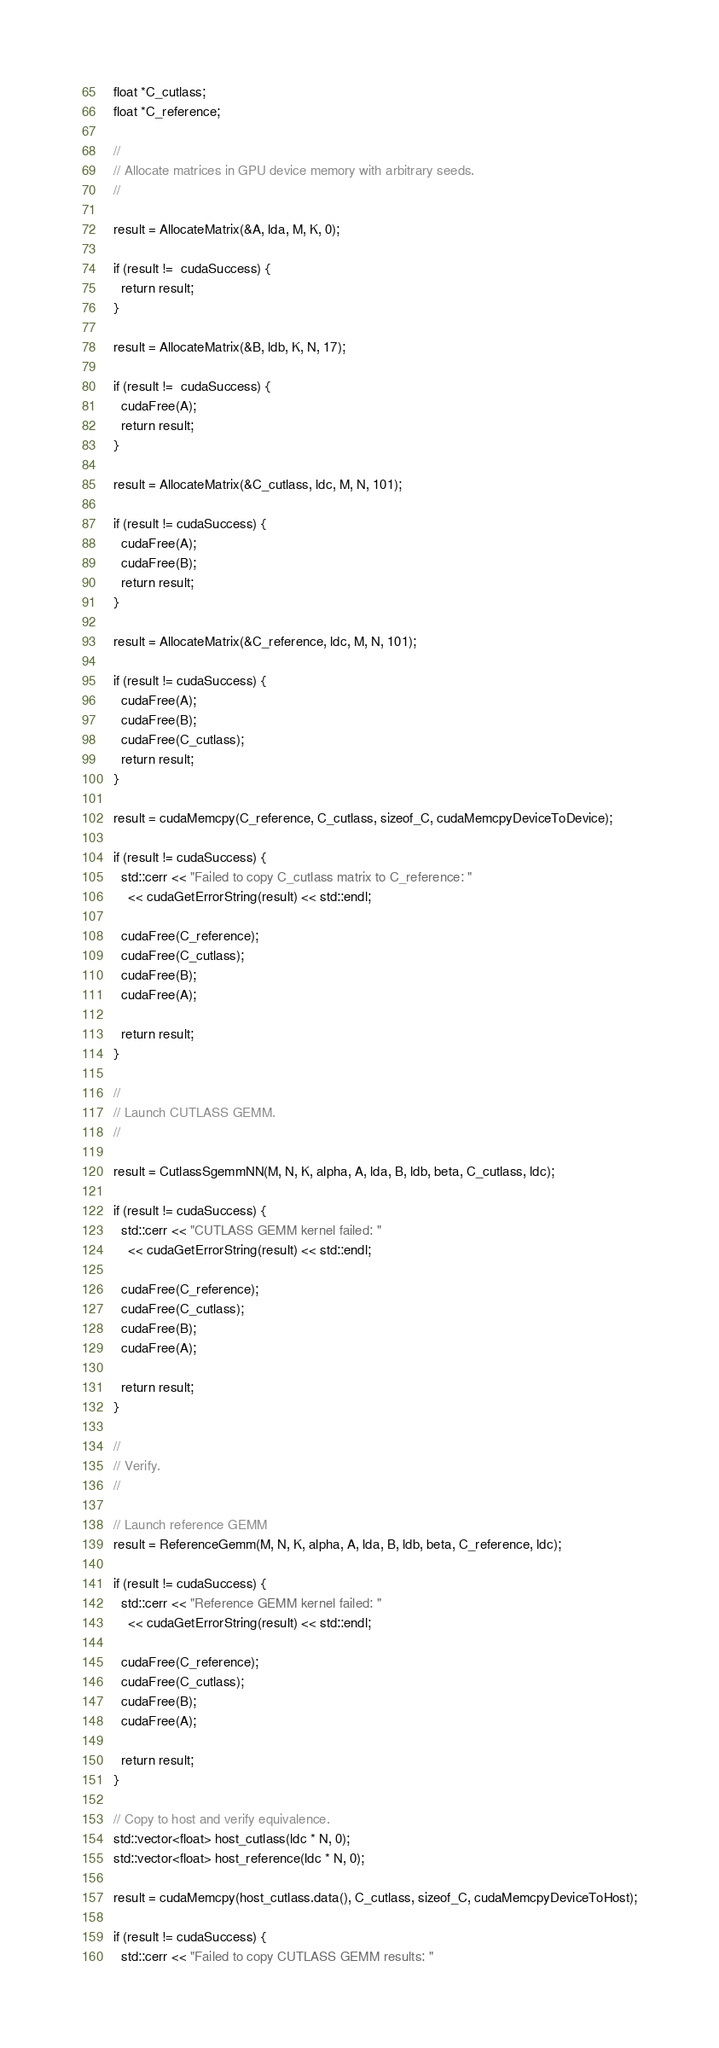Convert code to text. <code><loc_0><loc_0><loc_500><loc_500><_Cuda_>  float *C_cutlass;
  float *C_reference;

  //
  // Allocate matrices in GPU device memory with arbitrary seeds.
  //

  result = AllocateMatrix(&A, lda, M, K, 0);

  if (result !=  cudaSuccess) {
    return result;
  }

  result = AllocateMatrix(&B, ldb, K, N, 17);

  if (result !=  cudaSuccess) {
    cudaFree(A);
    return result;
  }

  result = AllocateMatrix(&C_cutlass, ldc, M, N, 101);

  if (result != cudaSuccess) {
    cudaFree(A);
    cudaFree(B);
    return result;
  }

  result = AllocateMatrix(&C_reference, ldc, M, N, 101);

  if (result != cudaSuccess) {
    cudaFree(A);
    cudaFree(B);
    cudaFree(C_cutlass);
    return result;
  }

  result = cudaMemcpy(C_reference, C_cutlass, sizeof_C, cudaMemcpyDeviceToDevice);

  if (result != cudaSuccess) {
    std::cerr << "Failed to copy C_cutlass matrix to C_reference: "
      << cudaGetErrorString(result) << std::endl;

    cudaFree(C_reference);
    cudaFree(C_cutlass);
    cudaFree(B);
    cudaFree(A);

    return result;
  }

  //
  // Launch CUTLASS GEMM.
  //

  result = CutlassSgemmNN(M, N, K, alpha, A, lda, B, ldb, beta, C_cutlass, ldc);

  if (result != cudaSuccess) {
    std::cerr << "CUTLASS GEMM kernel failed: "
      << cudaGetErrorString(result) << std::endl;

    cudaFree(C_reference);
    cudaFree(C_cutlass);
    cudaFree(B);
    cudaFree(A);

    return result;
  }

  //
  // Verify.
  //

  // Launch reference GEMM
  result = ReferenceGemm(M, N, K, alpha, A, lda, B, ldb, beta, C_reference, ldc);

  if (result != cudaSuccess) {
    std::cerr << "Reference GEMM kernel failed: "
      << cudaGetErrorString(result) << std::endl;

    cudaFree(C_reference);
    cudaFree(C_cutlass);
    cudaFree(B);
    cudaFree(A);

    return result;
  }

  // Copy to host and verify equivalence.
  std::vector<float> host_cutlass(ldc * N, 0);
  std::vector<float> host_reference(ldc * N, 0);

  result = cudaMemcpy(host_cutlass.data(), C_cutlass, sizeof_C, cudaMemcpyDeviceToHost);

  if (result != cudaSuccess) {
    std::cerr << "Failed to copy CUTLASS GEMM results: "</code> 